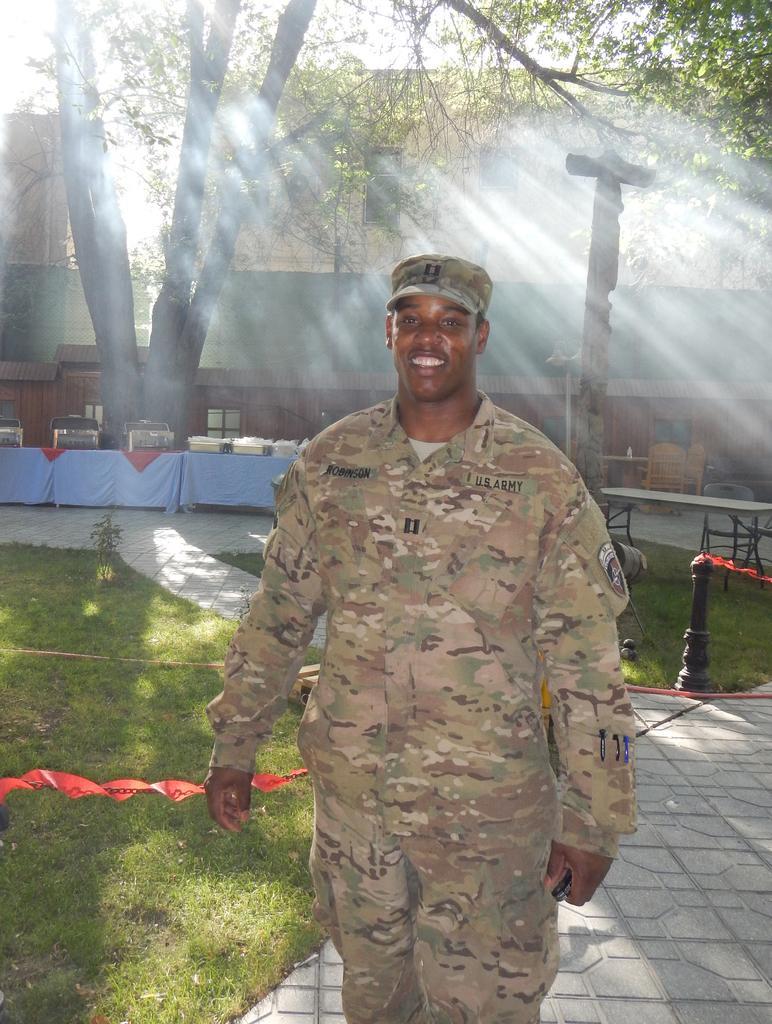How would you summarize this image in a sentence or two? In this picture I can see few buildings and I can see chairs and tables and I can see a man standing he wore a cap on his head and I can see smile on his face and I can see grass on the ground and few trees and a cloudy sky. 